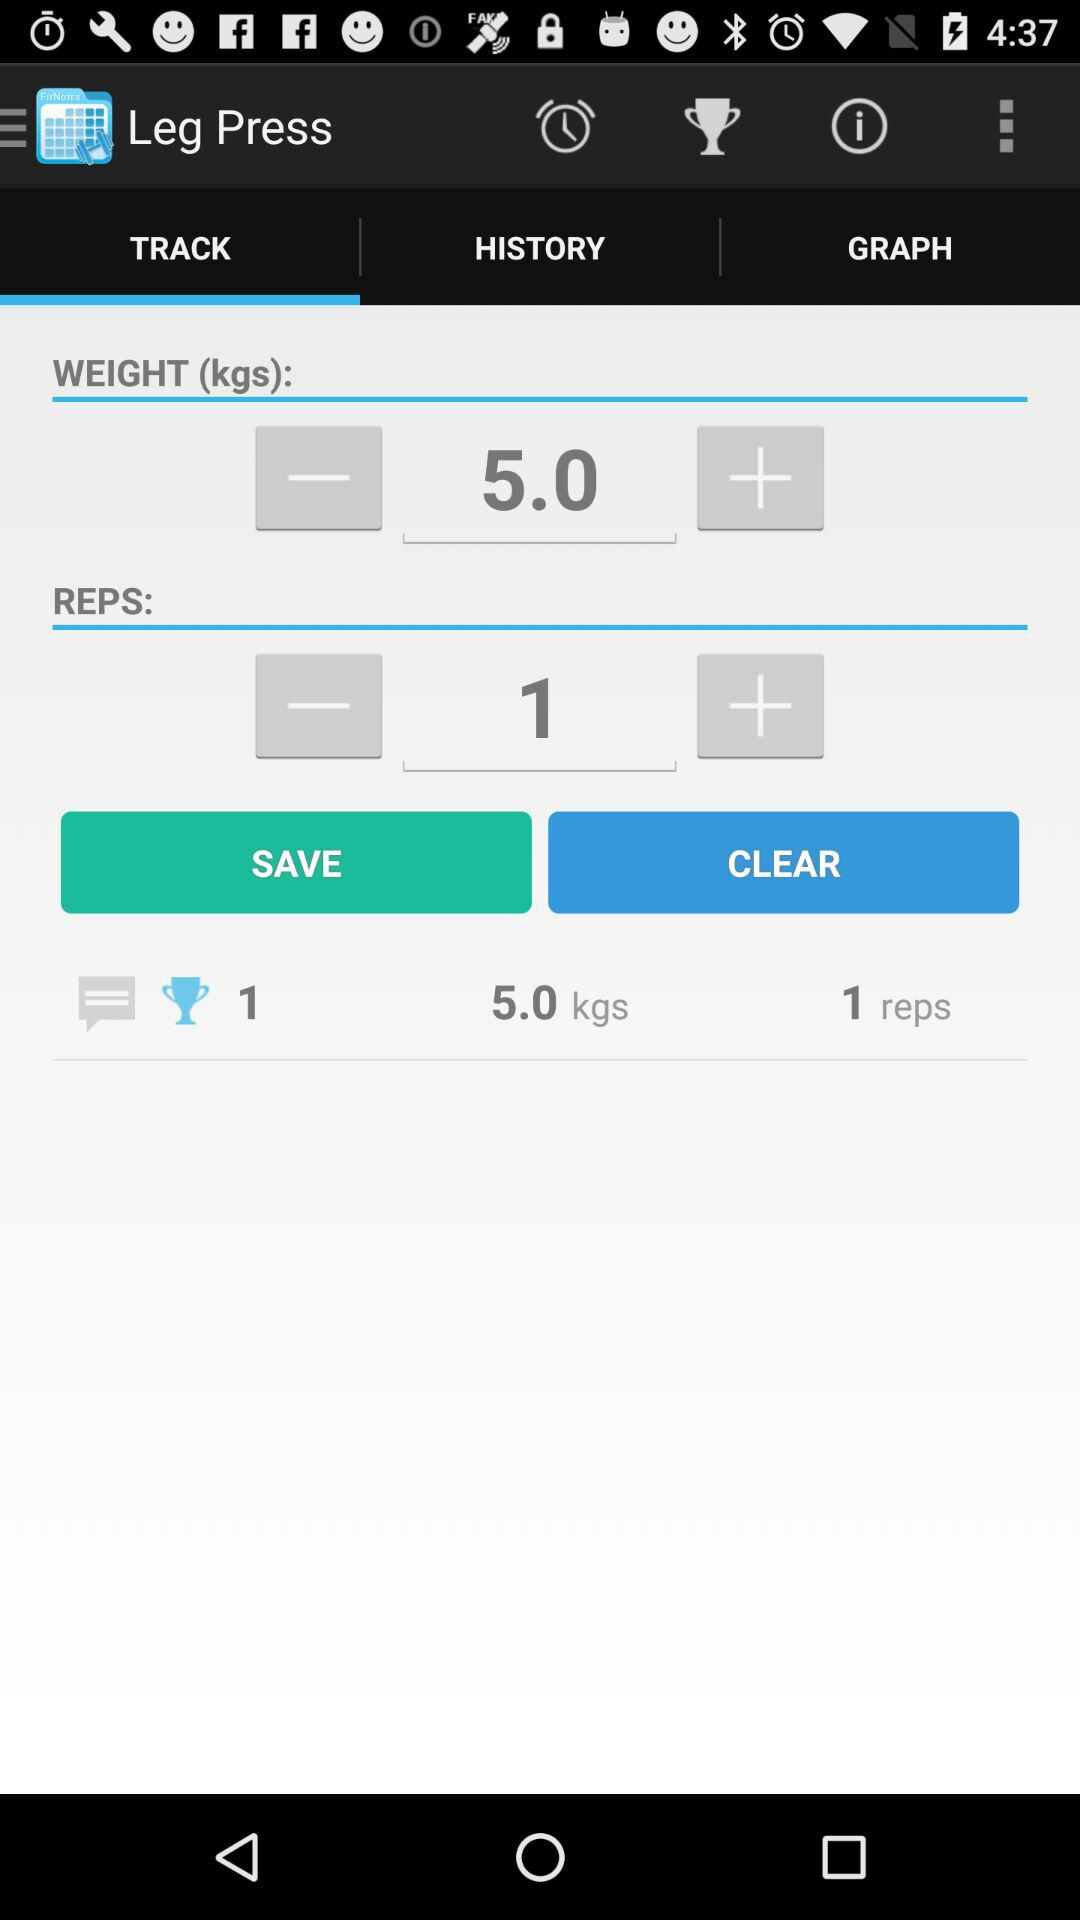Which tab is selected? The selected tab is "TRACK". 